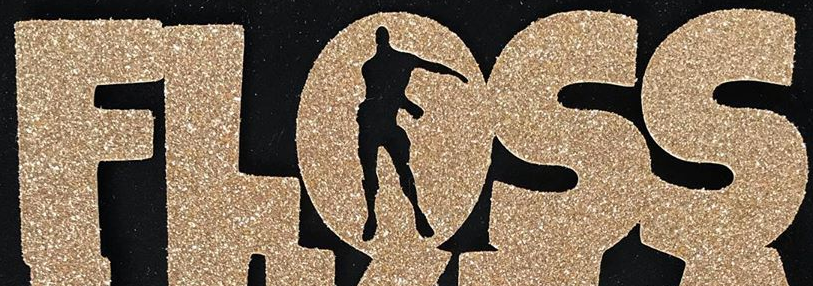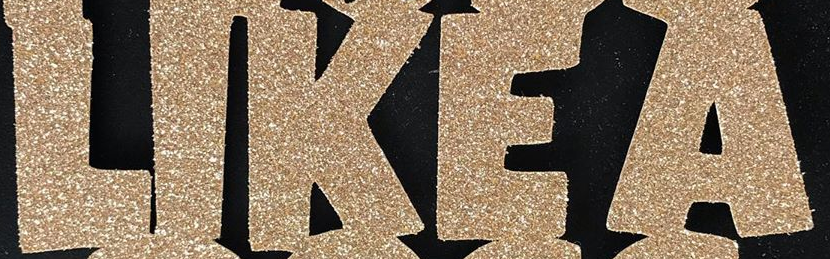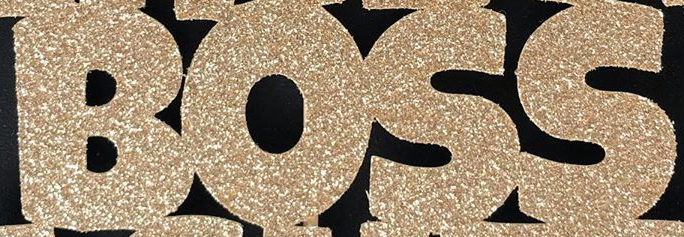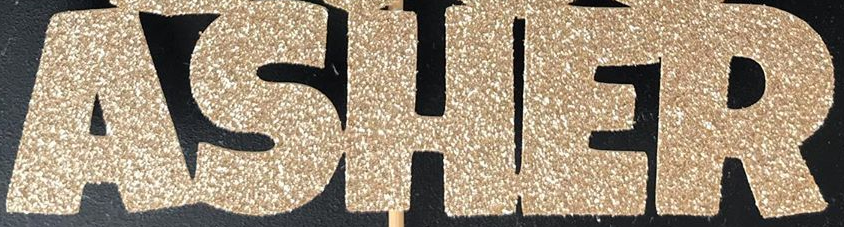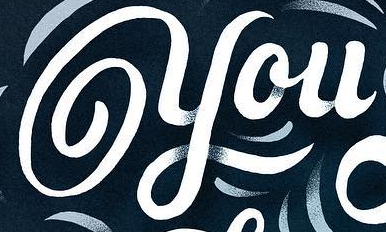What words are shown in these images in order, separated by a semicolon? FLOSS; LIKEA; BOSS; ASHER; you 